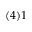<formula> <loc_0><loc_0><loc_500><loc_500>( 4 ) 1</formula> 